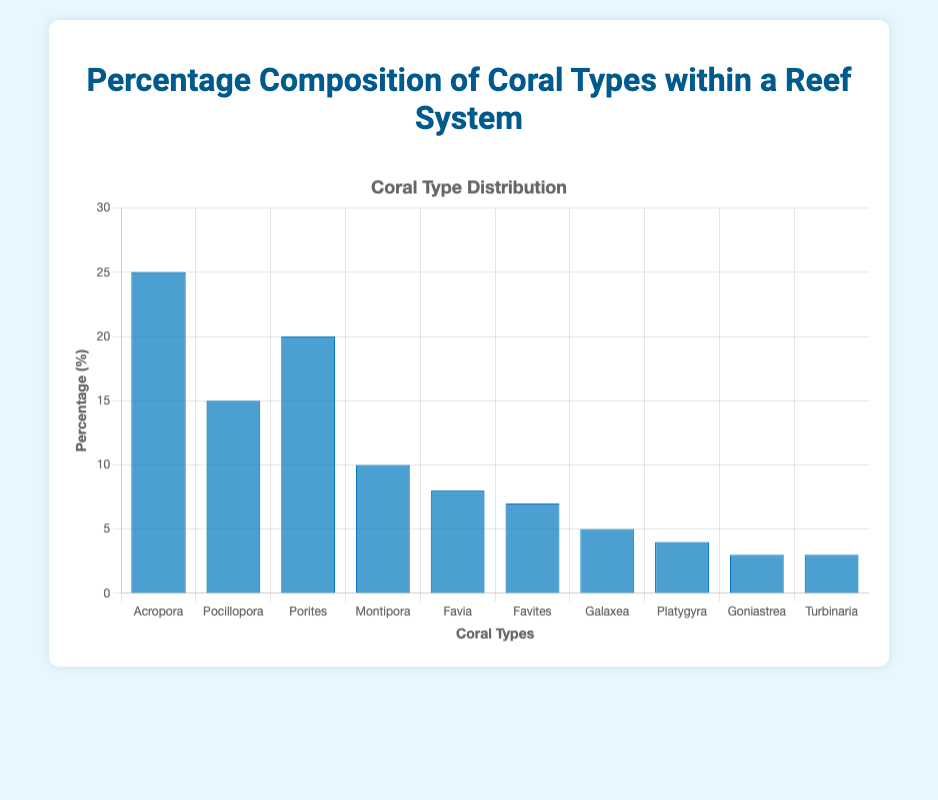How many coral types constitute more than 10% of the reef system? Identify the coral types with percentages greater than 10%: Acropora (25%), Pocillopora (15%), and Porites (20%). Count them.
Answer: 3 What is the total percentage of Montipora, Favia, and Favites combined? Sum the percentages of Montipora (10%), Favia (8%), and Favites (7%): 10 + 8 + 7 = 25%.
Answer: 25% Which coral type has the highest percentage composition? Identify the coral type with the highest percentage: Acropora at 25%.
Answer: Acropora How many coral types have a percentage composition of 5% or less? Identify coral types with percentages of 5% or less: Galaxea (5%), Platygyra (4%), Goniastrea (3%), and Turbinaria (3%). Count them.
Answer: 4 Which two coral types have the same percentage composition, and what is that percentage? Identify coral types with identical percentages: Goniastrea and Turbinaria both have 3%.
Answer: Goniastrea and Turbinaria, 3% How does the percentage of Pocillopora compare to Porites? Compare Pocillopora (15%) and Porites (20%): Porites is greater.
Answer: Porites > Pocillopora What is the difference in percentage between the highest and lowest percentage coral types? Identify highest (Acropora, 25%) and lowest (Goniastrea and Turbinaria, 3%) percentages. Calculate the difference: 25% - 3% = 22%.
Answer: 22% Which coral type is closest in percentage to Montipora? Identify Montipora's percentage (10%) and find the closest value: Favia (8%) is the closest.
Answer: Favia Is the percentage of Favia more than or equal to the sum of Goniastrea and Turbinaria? Compare Favia (8%) to the sum of Goniastrea (3%) and Turbinaria (3%): 3 + 3 = 6%, and 8% > 6%.
Answer: Yes 